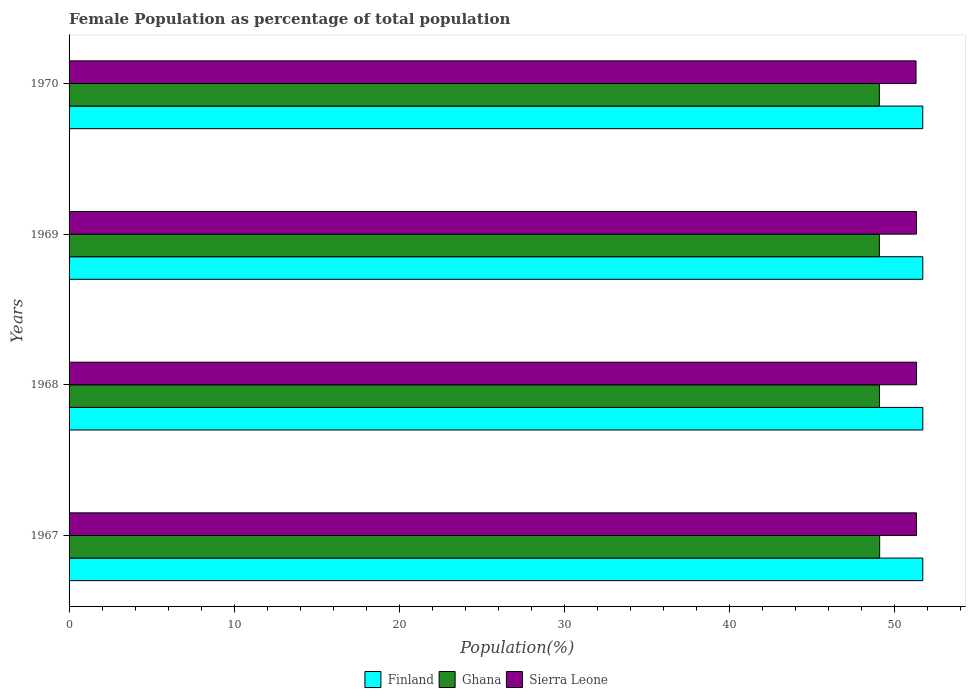How many groups of bars are there?
Make the answer very short. 4. Are the number of bars per tick equal to the number of legend labels?
Offer a terse response. Yes. In how many cases, is the number of bars for a given year not equal to the number of legend labels?
Your response must be concise. 0. What is the female population in in Sierra Leone in 1968?
Keep it short and to the point. 51.32. Across all years, what is the maximum female population in in Finland?
Offer a terse response. 51.7. Across all years, what is the minimum female population in in Sierra Leone?
Your answer should be very brief. 51.29. In which year was the female population in in Ghana maximum?
Your answer should be compact. 1967. What is the total female population in in Sierra Leone in the graph?
Keep it short and to the point. 205.25. What is the difference between the female population in in Sierra Leone in 1969 and that in 1970?
Make the answer very short. 0.02. What is the difference between the female population in in Sierra Leone in 1967 and the female population in in Ghana in 1968?
Provide a short and direct response. 2.24. What is the average female population in in Finland per year?
Offer a terse response. 51.7. In the year 1970, what is the difference between the female population in in Ghana and female population in in Sierra Leone?
Your response must be concise. -2.22. What is the ratio of the female population in in Ghana in 1969 to that in 1970?
Ensure brevity in your answer.  1. Is the female population in in Finland in 1969 less than that in 1970?
Ensure brevity in your answer.  No. What is the difference between the highest and the second highest female population in in Finland?
Your response must be concise. 7.898674500950165e-5. What is the difference between the highest and the lowest female population in in Finland?
Provide a short and direct response. 0. In how many years, is the female population in in Sierra Leone greater than the average female population in in Sierra Leone taken over all years?
Ensure brevity in your answer.  3. What does the 3rd bar from the bottom in 1968 represents?
Offer a very short reply. Sierra Leone. How many bars are there?
Provide a succinct answer. 12. What is the difference between two consecutive major ticks on the X-axis?
Your response must be concise. 10. Does the graph contain any zero values?
Keep it short and to the point. No. What is the title of the graph?
Offer a terse response. Female Population as percentage of total population. What is the label or title of the X-axis?
Keep it short and to the point. Population(%). What is the Population(%) of Finland in 1967?
Offer a very short reply. 51.7. What is the Population(%) in Ghana in 1967?
Your response must be concise. 49.09. What is the Population(%) in Sierra Leone in 1967?
Your answer should be compact. 51.32. What is the Population(%) of Finland in 1968?
Your answer should be compact. 51.7. What is the Population(%) in Ghana in 1968?
Your response must be concise. 49.08. What is the Population(%) of Sierra Leone in 1968?
Ensure brevity in your answer.  51.32. What is the Population(%) of Finland in 1969?
Offer a very short reply. 51.7. What is the Population(%) in Ghana in 1969?
Offer a very short reply. 49.07. What is the Population(%) of Sierra Leone in 1969?
Give a very brief answer. 51.31. What is the Population(%) in Finland in 1970?
Offer a terse response. 51.7. What is the Population(%) in Ghana in 1970?
Provide a succinct answer. 49.07. What is the Population(%) of Sierra Leone in 1970?
Offer a terse response. 51.29. Across all years, what is the maximum Population(%) of Finland?
Give a very brief answer. 51.7. Across all years, what is the maximum Population(%) of Ghana?
Your answer should be very brief. 49.09. Across all years, what is the maximum Population(%) in Sierra Leone?
Give a very brief answer. 51.32. Across all years, what is the minimum Population(%) in Finland?
Your response must be concise. 51.7. Across all years, what is the minimum Population(%) of Ghana?
Your answer should be very brief. 49.07. Across all years, what is the minimum Population(%) of Sierra Leone?
Ensure brevity in your answer.  51.29. What is the total Population(%) in Finland in the graph?
Offer a terse response. 206.8. What is the total Population(%) of Ghana in the graph?
Keep it short and to the point. 196.3. What is the total Population(%) of Sierra Leone in the graph?
Provide a short and direct response. 205.25. What is the difference between the Population(%) of Finland in 1967 and that in 1968?
Give a very brief answer. -0. What is the difference between the Population(%) of Ghana in 1967 and that in 1968?
Make the answer very short. 0.01. What is the difference between the Population(%) of Sierra Leone in 1967 and that in 1968?
Your answer should be very brief. -0. What is the difference between the Population(%) in Ghana in 1967 and that in 1969?
Provide a succinct answer. 0.02. What is the difference between the Population(%) of Sierra Leone in 1967 and that in 1969?
Keep it short and to the point. 0. What is the difference between the Population(%) in Finland in 1967 and that in 1970?
Your answer should be compact. 0. What is the difference between the Population(%) of Ghana in 1967 and that in 1970?
Provide a succinct answer. 0.02. What is the difference between the Population(%) of Sierra Leone in 1967 and that in 1970?
Provide a short and direct response. 0.03. What is the difference between the Population(%) in Finland in 1968 and that in 1969?
Keep it short and to the point. 0. What is the difference between the Population(%) of Ghana in 1968 and that in 1969?
Keep it short and to the point. 0.01. What is the difference between the Population(%) in Sierra Leone in 1968 and that in 1969?
Your response must be concise. 0.01. What is the difference between the Population(%) of Finland in 1968 and that in 1970?
Offer a very short reply. 0. What is the difference between the Population(%) of Ghana in 1968 and that in 1970?
Offer a very short reply. 0.01. What is the difference between the Population(%) in Sierra Leone in 1968 and that in 1970?
Offer a terse response. 0.03. What is the difference between the Population(%) in Finland in 1969 and that in 1970?
Provide a succinct answer. 0. What is the difference between the Population(%) of Ghana in 1969 and that in 1970?
Offer a very short reply. -0. What is the difference between the Population(%) of Sierra Leone in 1969 and that in 1970?
Ensure brevity in your answer.  0.02. What is the difference between the Population(%) of Finland in 1967 and the Population(%) of Ghana in 1968?
Provide a short and direct response. 2.62. What is the difference between the Population(%) of Finland in 1967 and the Population(%) of Sierra Leone in 1968?
Your response must be concise. 0.38. What is the difference between the Population(%) in Ghana in 1967 and the Population(%) in Sierra Leone in 1968?
Keep it short and to the point. -2.23. What is the difference between the Population(%) of Finland in 1967 and the Population(%) of Ghana in 1969?
Offer a terse response. 2.63. What is the difference between the Population(%) of Finland in 1967 and the Population(%) of Sierra Leone in 1969?
Give a very brief answer. 0.39. What is the difference between the Population(%) of Ghana in 1967 and the Population(%) of Sierra Leone in 1969?
Make the answer very short. -2.23. What is the difference between the Population(%) of Finland in 1967 and the Population(%) of Ghana in 1970?
Provide a succinct answer. 2.63. What is the difference between the Population(%) in Finland in 1967 and the Population(%) in Sierra Leone in 1970?
Give a very brief answer. 0.41. What is the difference between the Population(%) in Ghana in 1967 and the Population(%) in Sierra Leone in 1970?
Provide a short and direct response. -2.2. What is the difference between the Population(%) of Finland in 1968 and the Population(%) of Ghana in 1969?
Make the answer very short. 2.63. What is the difference between the Population(%) in Finland in 1968 and the Population(%) in Sierra Leone in 1969?
Provide a short and direct response. 0.39. What is the difference between the Population(%) of Ghana in 1968 and the Population(%) of Sierra Leone in 1969?
Your response must be concise. -2.24. What is the difference between the Population(%) of Finland in 1968 and the Population(%) of Ghana in 1970?
Offer a very short reply. 2.63. What is the difference between the Population(%) in Finland in 1968 and the Population(%) in Sierra Leone in 1970?
Provide a short and direct response. 0.41. What is the difference between the Population(%) in Ghana in 1968 and the Population(%) in Sierra Leone in 1970?
Give a very brief answer. -2.22. What is the difference between the Population(%) of Finland in 1969 and the Population(%) of Ghana in 1970?
Your answer should be very brief. 2.63. What is the difference between the Population(%) of Finland in 1969 and the Population(%) of Sierra Leone in 1970?
Your answer should be very brief. 0.41. What is the difference between the Population(%) of Ghana in 1969 and the Population(%) of Sierra Leone in 1970?
Offer a very short reply. -2.22. What is the average Population(%) in Finland per year?
Offer a terse response. 51.7. What is the average Population(%) of Ghana per year?
Make the answer very short. 49.08. What is the average Population(%) in Sierra Leone per year?
Provide a succinct answer. 51.31. In the year 1967, what is the difference between the Population(%) of Finland and Population(%) of Ghana?
Make the answer very short. 2.61. In the year 1967, what is the difference between the Population(%) in Finland and Population(%) in Sierra Leone?
Make the answer very short. 0.38. In the year 1967, what is the difference between the Population(%) of Ghana and Population(%) of Sierra Leone?
Provide a succinct answer. -2.23. In the year 1968, what is the difference between the Population(%) of Finland and Population(%) of Ghana?
Your answer should be compact. 2.62. In the year 1968, what is the difference between the Population(%) of Finland and Population(%) of Sierra Leone?
Offer a very short reply. 0.38. In the year 1968, what is the difference between the Population(%) of Ghana and Population(%) of Sierra Leone?
Offer a terse response. -2.25. In the year 1969, what is the difference between the Population(%) of Finland and Population(%) of Ghana?
Your answer should be compact. 2.63. In the year 1969, what is the difference between the Population(%) in Finland and Population(%) in Sierra Leone?
Give a very brief answer. 0.39. In the year 1969, what is the difference between the Population(%) of Ghana and Population(%) of Sierra Leone?
Your answer should be very brief. -2.24. In the year 1970, what is the difference between the Population(%) in Finland and Population(%) in Ghana?
Give a very brief answer. 2.63. In the year 1970, what is the difference between the Population(%) of Finland and Population(%) of Sierra Leone?
Offer a terse response. 0.41. In the year 1970, what is the difference between the Population(%) in Ghana and Population(%) in Sierra Leone?
Make the answer very short. -2.22. What is the ratio of the Population(%) of Ghana in 1967 to that in 1968?
Offer a terse response. 1. What is the ratio of the Population(%) in Sierra Leone in 1967 to that in 1968?
Give a very brief answer. 1. What is the ratio of the Population(%) in Ghana in 1967 to that in 1969?
Offer a terse response. 1. What is the ratio of the Population(%) of Sierra Leone in 1967 to that in 1970?
Keep it short and to the point. 1. What is the ratio of the Population(%) in Finland in 1968 to that in 1969?
Your answer should be compact. 1. What is the ratio of the Population(%) in Sierra Leone in 1968 to that in 1969?
Your response must be concise. 1. What is the ratio of the Population(%) in Sierra Leone in 1968 to that in 1970?
Provide a short and direct response. 1. What is the ratio of the Population(%) of Ghana in 1969 to that in 1970?
Make the answer very short. 1. What is the difference between the highest and the second highest Population(%) of Ghana?
Give a very brief answer. 0.01. What is the difference between the highest and the second highest Population(%) of Sierra Leone?
Ensure brevity in your answer.  0. What is the difference between the highest and the lowest Population(%) in Finland?
Provide a short and direct response. 0. What is the difference between the highest and the lowest Population(%) in Ghana?
Provide a succinct answer. 0.02. What is the difference between the highest and the lowest Population(%) of Sierra Leone?
Ensure brevity in your answer.  0.03. 